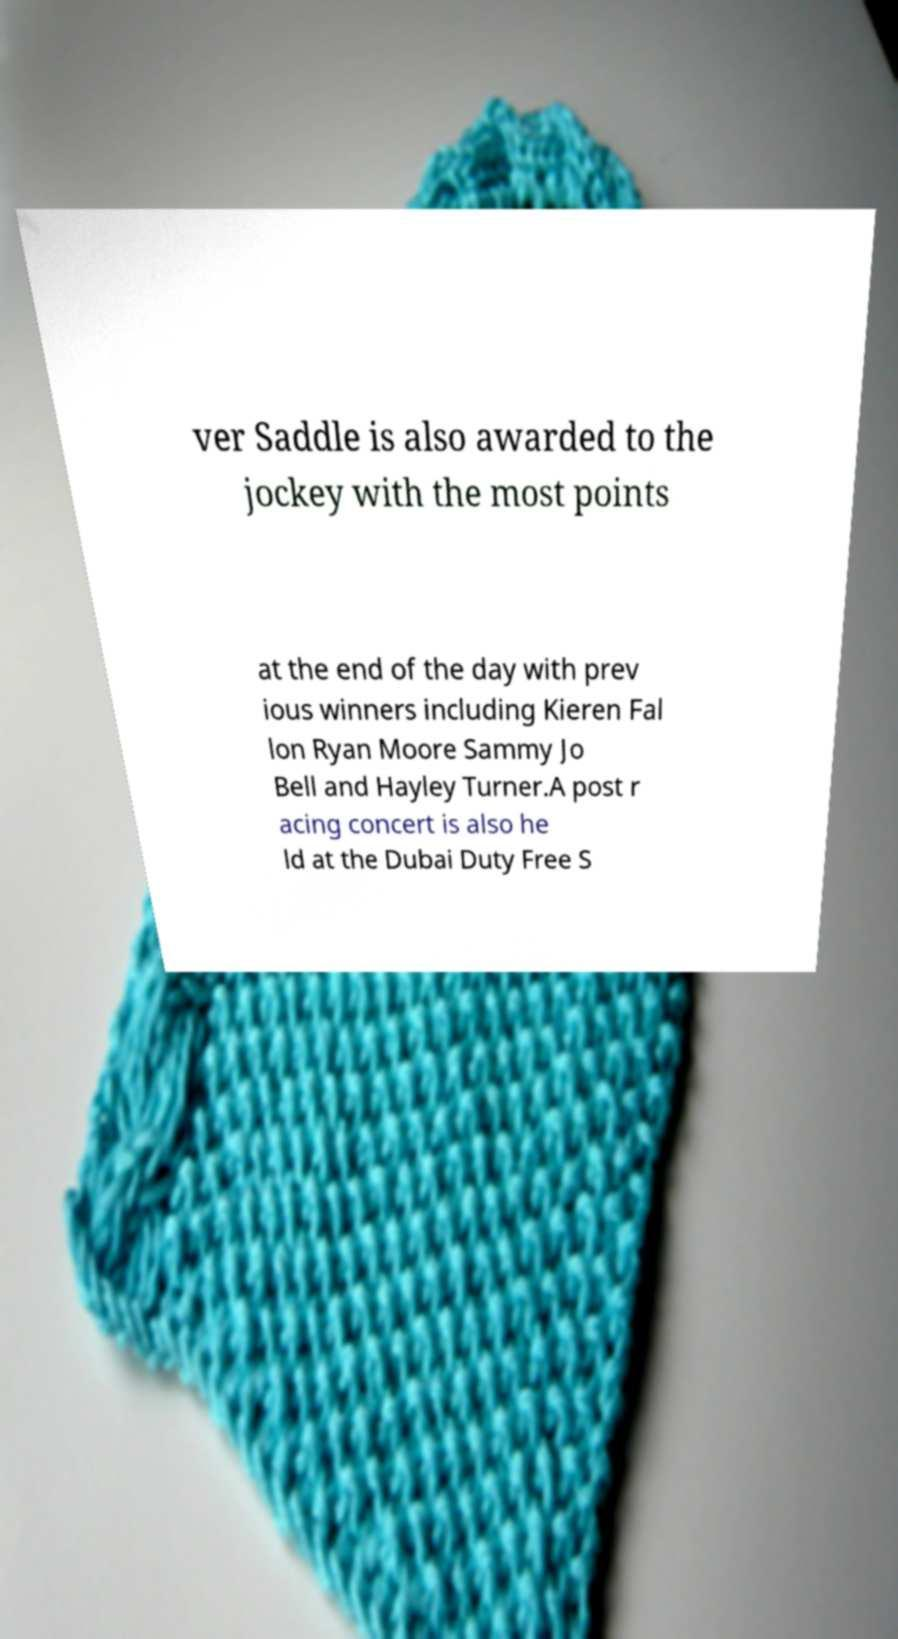I need the written content from this picture converted into text. Can you do that? ver Saddle is also awarded to the jockey with the most points at the end of the day with prev ious winners including Kieren Fal lon Ryan Moore Sammy Jo Bell and Hayley Turner.A post r acing concert is also he ld at the Dubai Duty Free S 